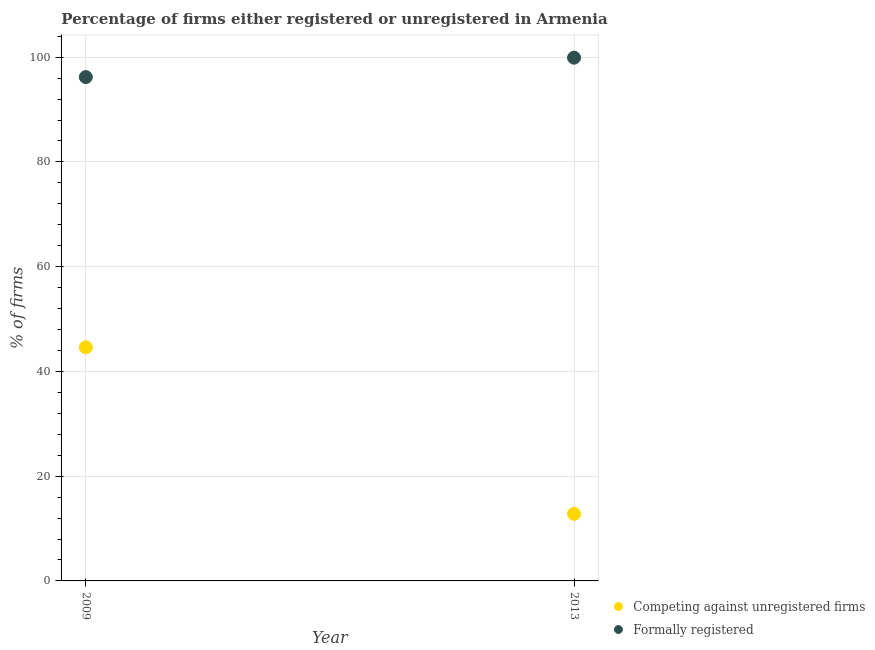Is the number of dotlines equal to the number of legend labels?
Make the answer very short. Yes. What is the percentage of formally registered firms in 2009?
Ensure brevity in your answer.  96.2. Across all years, what is the maximum percentage of formally registered firms?
Ensure brevity in your answer.  99.9. What is the total percentage of formally registered firms in the graph?
Make the answer very short. 196.1. What is the difference between the percentage of formally registered firms in 2009 and that in 2013?
Give a very brief answer. -3.7. What is the difference between the percentage of registered firms in 2013 and the percentage of formally registered firms in 2009?
Offer a terse response. -83.4. What is the average percentage of formally registered firms per year?
Ensure brevity in your answer.  98.05. In the year 2013, what is the difference between the percentage of formally registered firms and percentage of registered firms?
Provide a succinct answer. 87.1. What is the ratio of the percentage of registered firms in 2009 to that in 2013?
Your answer should be very brief. 3.48. In how many years, is the percentage of registered firms greater than the average percentage of registered firms taken over all years?
Your answer should be compact. 1. Does the percentage of formally registered firms monotonically increase over the years?
Offer a terse response. Yes. Is the percentage of registered firms strictly greater than the percentage of formally registered firms over the years?
Give a very brief answer. No. Is the percentage of registered firms strictly less than the percentage of formally registered firms over the years?
Your answer should be compact. Yes. Are the values on the major ticks of Y-axis written in scientific E-notation?
Your answer should be compact. No. Does the graph contain grids?
Offer a very short reply. Yes. Where does the legend appear in the graph?
Give a very brief answer. Bottom right. What is the title of the graph?
Offer a very short reply. Percentage of firms either registered or unregistered in Armenia. Does "Old" appear as one of the legend labels in the graph?
Provide a short and direct response. No. What is the label or title of the X-axis?
Your response must be concise. Year. What is the label or title of the Y-axis?
Give a very brief answer. % of firms. What is the % of firms in Competing against unregistered firms in 2009?
Offer a very short reply. 44.6. What is the % of firms in Formally registered in 2009?
Your response must be concise. 96.2. What is the % of firms of Competing against unregistered firms in 2013?
Offer a very short reply. 12.8. What is the % of firms in Formally registered in 2013?
Ensure brevity in your answer.  99.9. Across all years, what is the maximum % of firms in Competing against unregistered firms?
Keep it short and to the point. 44.6. Across all years, what is the maximum % of firms of Formally registered?
Keep it short and to the point. 99.9. Across all years, what is the minimum % of firms of Competing against unregistered firms?
Give a very brief answer. 12.8. Across all years, what is the minimum % of firms in Formally registered?
Your answer should be very brief. 96.2. What is the total % of firms of Competing against unregistered firms in the graph?
Ensure brevity in your answer.  57.4. What is the total % of firms of Formally registered in the graph?
Give a very brief answer. 196.1. What is the difference between the % of firms in Competing against unregistered firms in 2009 and that in 2013?
Provide a succinct answer. 31.8. What is the difference between the % of firms of Formally registered in 2009 and that in 2013?
Offer a very short reply. -3.7. What is the difference between the % of firms of Competing against unregistered firms in 2009 and the % of firms of Formally registered in 2013?
Provide a succinct answer. -55.3. What is the average % of firms of Competing against unregistered firms per year?
Keep it short and to the point. 28.7. What is the average % of firms in Formally registered per year?
Your answer should be compact. 98.05. In the year 2009, what is the difference between the % of firms of Competing against unregistered firms and % of firms of Formally registered?
Your answer should be very brief. -51.6. In the year 2013, what is the difference between the % of firms in Competing against unregistered firms and % of firms in Formally registered?
Give a very brief answer. -87.1. What is the ratio of the % of firms in Competing against unregistered firms in 2009 to that in 2013?
Give a very brief answer. 3.48. What is the ratio of the % of firms in Formally registered in 2009 to that in 2013?
Provide a short and direct response. 0.96. What is the difference between the highest and the second highest % of firms of Competing against unregistered firms?
Your response must be concise. 31.8. What is the difference between the highest and the lowest % of firms in Competing against unregistered firms?
Make the answer very short. 31.8. 